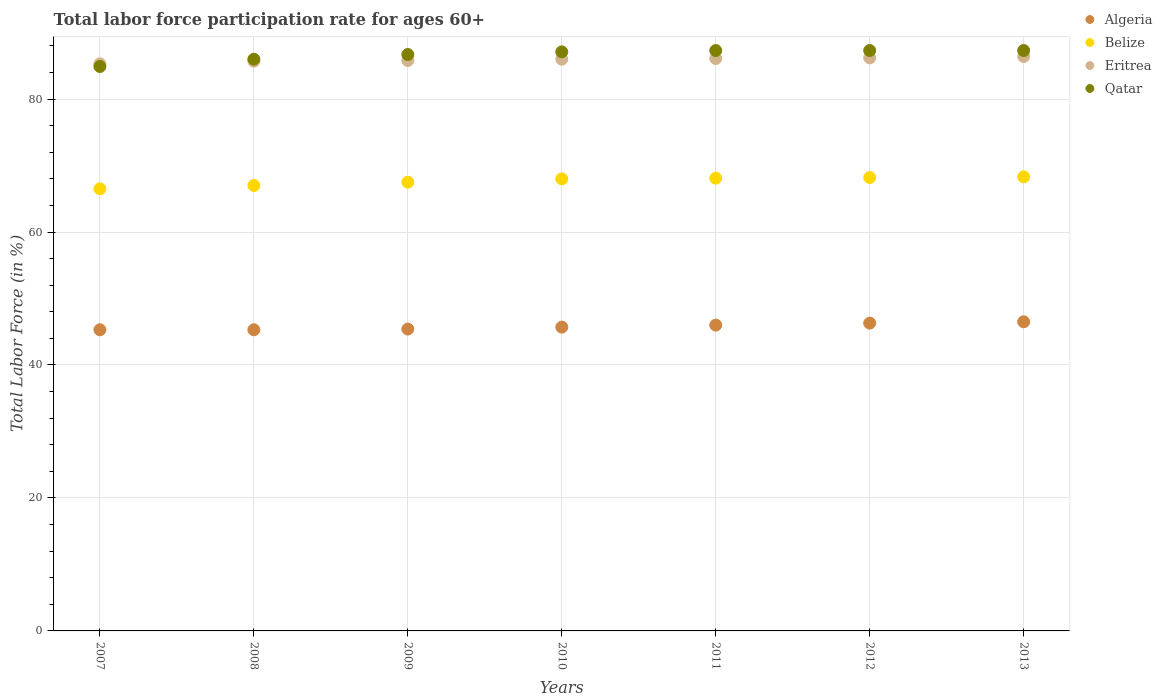How many different coloured dotlines are there?
Your response must be concise. 4. Is the number of dotlines equal to the number of legend labels?
Offer a very short reply. Yes. What is the labor force participation rate in Algeria in 2012?
Ensure brevity in your answer.  46.3. Across all years, what is the maximum labor force participation rate in Algeria?
Your response must be concise. 46.5. Across all years, what is the minimum labor force participation rate in Belize?
Your answer should be very brief. 66.5. What is the total labor force participation rate in Qatar in the graph?
Offer a very short reply. 606.6. What is the difference between the labor force participation rate in Belize in 2011 and that in 2012?
Provide a short and direct response. -0.1. What is the difference between the labor force participation rate in Belize in 2009 and the labor force participation rate in Eritrea in 2010?
Ensure brevity in your answer.  -18.5. What is the average labor force participation rate in Qatar per year?
Offer a very short reply. 86.66. In the year 2013, what is the difference between the labor force participation rate in Qatar and labor force participation rate in Algeria?
Offer a very short reply. 40.8. In how many years, is the labor force participation rate in Algeria greater than 84 %?
Offer a very short reply. 0. What is the ratio of the labor force participation rate in Qatar in 2009 to that in 2013?
Your response must be concise. 0.99. Is the labor force participation rate in Eritrea in 2011 less than that in 2013?
Offer a terse response. Yes. What is the difference between the highest and the second highest labor force participation rate in Qatar?
Provide a succinct answer. 0. What is the difference between the highest and the lowest labor force participation rate in Belize?
Provide a short and direct response. 1.8. Is it the case that in every year, the sum of the labor force participation rate in Belize and labor force participation rate in Qatar  is greater than the sum of labor force participation rate in Algeria and labor force participation rate in Eritrea?
Your answer should be very brief. Yes. Is the labor force participation rate in Eritrea strictly greater than the labor force participation rate in Qatar over the years?
Your response must be concise. No. Is the labor force participation rate in Algeria strictly less than the labor force participation rate in Eritrea over the years?
Your answer should be very brief. Yes. How many dotlines are there?
Offer a terse response. 4. What is the difference between two consecutive major ticks on the Y-axis?
Keep it short and to the point. 20. Does the graph contain any zero values?
Keep it short and to the point. No. Does the graph contain grids?
Your answer should be compact. Yes. What is the title of the graph?
Provide a short and direct response. Total labor force participation rate for ages 60+. What is the Total Labor Force (in %) in Algeria in 2007?
Provide a short and direct response. 45.3. What is the Total Labor Force (in %) in Belize in 2007?
Make the answer very short. 66.5. What is the Total Labor Force (in %) of Eritrea in 2007?
Provide a short and direct response. 85.3. What is the Total Labor Force (in %) of Qatar in 2007?
Make the answer very short. 84.9. What is the Total Labor Force (in %) in Algeria in 2008?
Give a very brief answer. 45.3. What is the Total Labor Force (in %) in Eritrea in 2008?
Ensure brevity in your answer.  85.7. What is the Total Labor Force (in %) of Qatar in 2008?
Provide a succinct answer. 86. What is the Total Labor Force (in %) in Algeria in 2009?
Keep it short and to the point. 45.4. What is the Total Labor Force (in %) of Belize in 2009?
Ensure brevity in your answer.  67.5. What is the Total Labor Force (in %) in Eritrea in 2009?
Your response must be concise. 85.8. What is the Total Labor Force (in %) of Qatar in 2009?
Offer a terse response. 86.7. What is the Total Labor Force (in %) in Algeria in 2010?
Make the answer very short. 45.7. What is the Total Labor Force (in %) in Belize in 2010?
Provide a short and direct response. 68. What is the Total Labor Force (in %) of Eritrea in 2010?
Keep it short and to the point. 86. What is the Total Labor Force (in %) of Qatar in 2010?
Your answer should be very brief. 87.1. What is the Total Labor Force (in %) in Algeria in 2011?
Keep it short and to the point. 46. What is the Total Labor Force (in %) in Belize in 2011?
Your response must be concise. 68.1. What is the Total Labor Force (in %) in Eritrea in 2011?
Make the answer very short. 86.1. What is the Total Labor Force (in %) in Qatar in 2011?
Give a very brief answer. 87.3. What is the Total Labor Force (in %) in Algeria in 2012?
Make the answer very short. 46.3. What is the Total Labor Force (in %) of Belize in 2012?
Keep it short and to the point. 68.2. What is the Total Labor Force (in %) in Eritrea in 2012?
Your response must be concise. 86.2. What is the Total Labor Force (in %) in Qatar in 2012?
Ensure brevity in your answer.  87.3. What is the Total Labor Force (in %) in Algeria in 2013?
Your answer should be very brief. 46.5. What is the Total Labor Force (in %) in Belize in 2013?
Your answer should be compact. 68.3. What is the Total Labor Force (in %) in Eritrea in 2013?
Your answer should be compact. 86.4. What is the Total Labor Force (in %) of Qatar in 2013?
Offer a terse response. 87.3. Across all years, what is the maximum Total Labor Force (in %) in Algeria?
Provide a succinct answer. 46.5. Across all years, what is the maximum Total Labor Force (in %) of Belize?
Your answer should be compact. 68.3. Across all years, what is the maximum Total Labor Force (in %) of Eritrea?
Provide a short and direct response. 86.4. Across all years, what is the maximum Total Labor Force (in %) of Qatar?
Ensure brevity in your answer.  87.3. Across all years, what is the minimum Total Labor Force (in %) of Algeria?
Offer a terse response. 45.3. Across all years, what is the minimum Total Labor Force (in %) of Belize?
Provide a succinct answer. 66.5. Across all years, what is the minimum Total Labor Force (in %) in Eritrea?
Offer a very short reply. 85.3. Across all years, what is the minimum Total Labor Force (in %) of Qatar?
Give a very brief answer. 84.9. What is the total Total Labor Force (in %) in Algeria in the graph?
Offer a terse response. 320.5. What is the total Total Labor Force (in %) of Belize in the graph?
Give a very brief answer. 473.6. What is the total Total Labor Force (in %) in Eritrea in the graph?
Give a very brief answer. 601.5. What is the total Total Labor Force (in %) in Qatar in the graph?
Provide a succinct answer. 606.6. What is the difference between the Total Labor Force (in %) of Algeria in 2007 and that in 2008?
Your response must be concise. 0. What is the difference between the Total Labor Force (in %) in Belize in 2007 and that in 2008?
Ensure brevity in your answer.  -0.5. What is the difference between the Total Labor Force (in %) in Eritrea in 2007 and that in 2008?
Offer a very short reply. -0.4. What is the difference between the Total Labor Force (in %) in Qatar in 2007 and that in 2009?
Your answer should be compact. -1.8. What is the difference between the Total Labor Force (in %) in Algeria in 2007 and that in 2011?
Keep it short and to the point. -0.7. What is the difference between the Total Labor Force (in %) in Belize in 2007 and that in 2011?
Provide a short and direct response. -1.6. What is the difference between the Total Labor Force (in %) of Eritrea in 2007 and that in 2011?
Keep it short and to the point. -0.8. What is the difference between the Total Labor Force (in %) in Qatar in 2007 and that in 2011?
Keep it short and to the point. -2.4. What is the difference between the Total Labor Force (in %) of Eritrea in 2007 and that in 2012?
Keep it short and to the point. -0.9. What is the difference between the Total Labor Force (in %) of Qatar in 2007 and that in 2012?
Offer a very short reply. -2.4. What is the difference between the Total Labor Force (in %) in Algeria in 2007 and that in 2013?
Keep it short and to the point. -1.2. What is the difference between the Total Labor Force (in %) in Belize in 2007 and that in 2013?
Your answer should be very brief. -1.8. What is the difference between the Total Labor Force (in %) in Qatar in 2007 and that in 2013?
Your answer should be very brief. -2.4. What is the difference between the Total Labor Force (in %) in Qatar in 2008 and that in 2009?
Give a very brief answer. -0.7. What is the difference between the Total Labor Force (in %) in Qatar in 2008 and that in 2011?
Make the answer very short. -1.3. What is the difference between the Total Labor Force (in %) in Eritrea in 2008 and that in 2012?
Keep it short and to the point. -0.5. What is the difference between the Total Labor Force (in %) of Eritrea in 2008 and that in 2013?
Offer a terse response. -0.7. What is the difference between the Total Labor Force (in %) in Qatar in 2008 and that in 2013?
Your answer should be compact. -1.3. What is the difference between the Total Labor Force (in %) of Algeria in 2009 and that in 2010?
Provide a short and direct response. -0.3. What is the difference between the Total Labor Force (in %) in Belize in 2009 and that in 2010?
Your response must be concise. -0.5. What is the difference between the Total Labor Force (in %) of Qatar in 2009 and that in 2010?
Provide a succinct answer. -0.4. What is the difference between the Total Labor Force (in %) of Belize in 2009 and that in 2011?
Make the answer very short. -0.6. What is the difference between the Total Labor Force (in %) in Eritrea in 2009 and that in 2011?
Your response must be concise. -0.3. What is the difference between the Total Labor Force (in %) of Qatar in 2009 and that in 2011?
Your answer should be very brief. -0.6. What is the difference between the Total Labor Force (in %) of Belize in 2009 and that in 2012?
Offer a very short reply. -0.7. What is the difference between the Total Labor Force (in %) of Eritrea in 2009 and that in 2012?
Offer a very short reply. -0.4. What is the difference between the Total Labor Force (in %) in Eritrea in 2009 and that in 2013?
Your answer should be very brief. -0.6. What is the difference between the Total Labor Force (in %) of Qatar in 2009 and that in 2013?
Keep it short and to the point. -0.6. What is the difference between the Total Labor Force (in %) in Algeria in 2010 and that in 2011?
Keep it short and to the point. -0.3. What is the difference between the Total Labor Force (in %) in Eritrea in 2010 and that in 2011?
Give a very brief answer. -0.1. What is the difference between the Total Labor Force (in %) of Algeria in 2010 and that in 2012?
Offer a terse response. -0.6. What is the difference between the Total Labor Force (in %) in Eritrea in 2010 and that in 2012?
Give a very brief answer. -0.2. What is the difference between the Total Labor Force (in %) of Algeria in 2010 and that in 2013?
Your response must be concise. -0.8. What is the difference between the Total Labor Force (in %) of Belize in 2010 and that in 2013?
Give a very brief answer. -0.3. What is the difference between the Total Labor Force (in %) of Qatar in 2010 and that in 2013?
Keep it short and to the point. -0.2. What is the difference between the Total Labor Force (in %) in Eritrea in 2011 and that in 2012?
Keep it short and to the point. -0.1. What is the difference between the Total Labor Force (in %) in Belize in 2011 and that in 2013?
Your answer should be compact. -0.2. What is the difference between the Total Labor Force (in %) of Eritrea in 2011 and that in 2013?
Your response must be concise. -0.3. What is the difference between the Total Labor Force (in %) of Qatar in 2011 and that in 2013?
Make the answer very short. 0. What is the difference between the Total Labor Force (in %) in Algeria in 2012 and that in 2013?
Your answer should be very brief. -0.2. What is the difference between the Total Labor Force (in %) in Qatar in 2012 and that in 2013?
Provide a short and direct response. 0. What is the difference between the Total Labor Force (in %) in Algeria in 2007 and the Total Labor Force (in %) in Belize in 2008?
Ensure brevity in your answer.  -21.7. What is the difference between the Total Labor Force (in %) of Algeria in 2007 and the Total Labor Force (in %) of Eritrea in 2008?
Your answer should be very brief. -40.4. What is the difference between the Total Labor Force (in %) in Algeria in 2007 and the Total Labor Force (in %) in Qatar in 2008?
Your response must be concise. -40.7. What is the difference between the Total Labor Force (in %) in Belize in 2007 and the Total Labor Force (in %) in Eritrea in 2008?
Offer a very short reply. -19.2. What is the difference between the Total Labor Force (in %) in Belize in 2007 and the Total Labor Force (in %) in Qatar in 2008?
Make the answer very short. -19.5. What is the difference between the Total Labor Force (in %) in Eritrea in 2007 and the Total Labor Force (in %) in Qatar in 2008?
Offer a terse response. -0.7. What is the difference between the Total Labor Force (in %) of Algeria in 2007 and the Total Labor Force (in %) of Belize in 2009?
Provide a short and direct response. -22.2. What is the difference between the Total Labor Force (in %) in Algeria in 2007 and the Total Labor Force (in %) in Eritrea in 2009?
Provide a succinct answer. -40.5. What is the difference between the Total Labor Force (in %) of Algeria in 2007 and the Total Labor Force (in %) of Qatar in 2009?
Your response must be concise. -41.4. What is the difference between the Total Labor Force (in %) in Belize in 2007 and the Total Labor Force (in %) in Eritrea in 2009?
Make the answer very short. -19.3. What is the difference between the Total Labor Force (in %) in Belize in 2007 and the Total Labor Force (in %) in Qatar in 2009?
Make the answer very short. -20.2. What is the difference between the Total Labor Force (in %) of Eritrea in 2007 and the Total Labor Force (in %) of Qatar in 2009?
Offer a very short reply. -1.4. What is the difference between the Total Labor Force (in %) in Algeria in 2007 and the Total Labor Force (in %) in Belize in 2010?
Your response must be concise. -22.7. What is the difference between the Total Labor Force (in %) in Algeria in 2007 and the Total Labor Force (in %) in Eritrea in 2010?
Provide a short and direct response. -40.7. What is the difference between the Total Labor Force (in %) in Algeria in 2007 and the Total Labor Force (in %) in Qatar in 2010?
Make the answer very short. -41.8. What is the difference between the Total Labor Force (in %) of Belize in 2007 and the Total Labor Force (in %) of Eritrea in 2010?
Your response must be concise. -19.5. What is the difference between the Total Labor Force (in %) of Belize in 2007 and the Total Labor Force (in %) of Qatar in 2010?
Keep it short and to the point. -20.6. What is the difference between the Total Labor Force (in %) in Algeria in 2007 and the Total Labor Force (in %) in Belize in 2011?
Your answer should be very brief. -22.8. What is the difference between the Total Labor Force (in %) of Algeria in 2007 and the Total Labor Force (in %) of Eritrea in 2011?
Provide a short and direct response. -40.8. What is the difference between the Total Labor Force (in %) in Algeria in 2007 and the Total Labor Force (in %) in Qatar in 2011?
Your response must be concise. -42. What is the difference between the Total Labor Force (in %) in Belize in 2007 and the Total Labor Force (in %) in Eritrea in 2011?
Provide a short and direct response. -19.6. What is the difference between the Total Labor Force (in %) in Belize in 2007 and the Total Labor Force (in %) in Qatar in 2011?
Your response must be concise. -20.8. What is the difference between the Total Labor Force (in %) in Algeria in 2007 and the Total Labor Force (in %) in Belize in 2012?
Make the answer very short. -22.9. What is the difference between the Total Labor Force (in %) of Algeria in 2007 and the Total Labor Force (in %) of Eritrea in 2012?
Keep it short and to the point. -40.9. What is the difference between the Total Labor Force (in %) of Algeria in 2007 and the Total Labor Force (in %) of Qatar in 2012?
Provide a short and direct response. -42. What is the difference between the Total Labor Force (in %) of Belize in 2007 and the Total Labor Force (in %) of Eritrea in 2012?
Offer a terse response. -19.7. What is the difference between the Total Labor Force (in %) of Belize in 2007 and the Total Labor Force (in %) of Qatar in 2012?
Offer a very short reply. -20.8. What is the difference between the Total Labor Force (in %) of Eritrea in 2007 and the Total Labor Force (in %) of Qatar in 2012?
Offer a terse response. -2. What is the difference between the Total Labor Force (in %) in Algeria in 2007 and the Total Labor Force (in %) in Belize in 2013?
Your response must be concise. -23. What is the difference between the Total Labor Force (in %) of Algeria in 2007 and the Total Labor Force (in %) of Eritrea in 2013?
Make the answer very short. -41.1. What is the difference between the Total Labor Force (in %) of Algeria in 2007 and the Total Labor Force (in %) of Qatar in 2013?
Offer a very short reply. -42. What is the difference between the Total Labor Force (in %) of Belize in 2007 and the Total Labor Force (in %) of Eritrea in 2013?
Offer a terse response. -19.9. What is the difference between the Total Labor Force (in %) of Belize in 2007 and the Total Labor Force (in %) of Qatar in 2013?
Give a very brief answer. -20.8. What is the difference between the Total Labor Force (in %) in Algeria in 2008 and the Total Labor Force (in %) in Belize in 2009?
Your response must be concise. -22.2. What is the difference between the Total Labor Force (in %) of Algeria in 2008 and the Total Labor Force (in %) of Eritrea in 2009?
Keep it short and to the point. -40.5. What is the difference between the Total Labor Force (in %) in Algeria in 2008 and the Total Labor Force (in %) in Qatar in 2009?
Your response must be concise. -41.4. What is the difference between the Total Labor Force (in %) of Belize in 2008 and the Total Labor Force (in %) of Eritrea in 2009?
Your answer should be very brief. -18.8. What is the difference between the Total Labor Force (in %) in Belize in 2008 and the Total Labor Force (in %) in Qatar in 2009?
Offer a terse response. -19.7. What is the difference between the Total Labor Force (in %) in Eritrea in 2008 and the Total Labor Force (in %) in Qatar in 2009?
Your response must be concise. -1. What is the difference between the Total Labor Force (in %) in Algeria in 2008 and the Total Labor Force (in %) in Belize in 2010?
Your answer should be compact. -22.7. What is the difference between the Total Labor Force (in %) in Algeria in 2008 and the Total Labor Force (in %) in Eritrea in 2010?
Keep it short and to the point. -40.7. What is the difference between the Total Labor Force (in %) of Algeria in 2008 and the Total Labor Force (in %) of Qatar in 2010?
Your response must be concise. -41.8. What is the difference between the Total Labor Force (in %) in Belize in 2008 and the Total Labor Force (in %) in Qatar in 2010?
Keep it short and to the point. -20.1. What is the difference between the Total Labor Force (in %) in Algeria in 2008 and the Total Labor Force (in %) in Belize in 2011?
Offer a very short reply. -22.8. What is the difference between the Total Labor Force (in %) of Algeria in 2008 and the Total Labor Force (in %) of Eritrea in 2011?
Give a very brief answer. -40.8. What is the difference between the Total Labor Force (in %) of Algeria in 2008 and the Total Labor Force (in %) of Qatar in 2011?
Your answer should be compact. -42. What is the difference between the Total Labor Force (in %) in Belize in 2008 and the Total Labor Force (in %) in Eritrea in 2011?
Provide a succinct answer. -19.1. What is the difference between the Total Labor Force (in %) of Belize in 2008 and the Total Labor Force (in %) of Qatar in 2011?
Keep it short and to the point. -20.3. What is the difference between the Total Labor Force (in %) of Algeria in 2008 and the Total Labor Force (in %) of Belize in 2012?
Offer a terse response. -22.9. What is the difference between the Total Labor Force (in %) of Algeria in 2008 and the Total Labor Force (in %) of Eritrea in 2012?
Your answer should be very brief. -40.9. What is the difference between the Total Labor Force (in %) in Algeria in 2008 and the Total Labor Force (in %) in Qatar in 2012?
Give a very brief answer. -42. What is the difference between the Total Labor Force (in %) of Belize in 2008 and the Total Labor Force (in %) of Eritrea in 2012?
Your answer should be compact. -19.2. What is the difference between the Total Labor Force (in %) in Belize in 2008 and the Total Labor Force (in %) in Qatar in 2012?
Your answer should be very brief. -20.3. What is the difference between the Total Labor Force (in %) of Algeria in 2008 and the Total Labor Force (in %) of Belize in 2013?
Ensure brevity in your answer.  -23. What is the difference between the Total Labor Force (in %) in Algeria in 2008 and the Total Labor Force (in %) in Eritrea in 2013?
Provide a succinct answer. -41.1. What is the difference between the Total Labor Force (in %) of Algeria in 2008 and the Total Labor Force (in %) of Qatar in 2013?
Provide a short and direct response. -42. What is the difference between the Total Labor Force (in %) in Belize in 2008 and the Total Labor Force (in %) in Eritrea in 2013?
Your answer should be compact. -19.4. What is the difference between the Total Labor Force (in %) in Belize in 2008 and the Total Labor Force (in %) in Qatar in 2013?
Ensure brevity in your answer.  -20.3. What is the difference between the Total Labor Force (in %) of Algeria in 2009 and the Total Labor Force (in %) of Belize in 2010?
Your response must be concise. -22.6. What is the difference between the Total Labor Force (in %) in Algeria in 2009 and the Total Labor Force (in %) in Eritrea in 2010?
Your answer should be compact. -40.6. What is the difference between the Total Labor Force (in %) of Algeria in 2009 and the Total Labor Force (in %) of Qatar in 2010?
Offer a terse response. -41.7. What is the difference between the Total Labor Force (in %) of Belize in 2009 and the Total Labor Force (in %) of Eritrea in 2010?
Make the answer very short. -18.5. What is the difference between the Total Labor Force (in %) in Belize in 2009 and the Total Labor Force (in %) in Qatar in 2010?
Your answer should be compact. -19.6. What is the difference between the Total Labor Force (in %) of Eritrea in 2009 and the Total Labor Force (in %) of Qatar in 2010?
Offer a terse response. -1.3. What is the difference between the Total Labor Force (in %) of Algeria in 2009 and the Total Labor Force (in %) of Belize in 2011?
Offer a very short reply. -22.7. What is the difference between the Total Labor Force (in %) in Algeria in 2009 and the Total Labor Force (in %) in Eritrea in 2011?
Your answer should be compact. -40.7. What is the difference between the Total Labor Force (in %) in Algeria in 2009 and the Total Labor Force (in %) in Qatar in 2011?
Give a very brief answer. -41.9. What is the difference between the Total Labor Force (in %) of Belize in 2009 and the Total Labor Force (in %) of Eritrea in 2011?
Your response must be concise. -18.6. What is the difference between the Total Labor Force (in %) in Belize in 2009 and the Total Labor Force (in %) in Qatar in 2011?
Offer a very short reply. -19.8. What is the difference between the Total Labor Force (in %) of Algeria in 2009 and the Total Labor Force (in %) of Belize in 2012?
Offer a terse response. -22.8. What is the difference between the Total Labor Force (in %) in Algeria in 2009 and the Total Labor Force (in %) in Eritrea in 2012?
Your answer should be very brief. -40.8. What is the difference between the Total Labor Force (in %) of Algeria in 2009 and the Total Labor Force (in %) of Qatar in 2012?
Provide a succinct answer. -41.9. What is the difference between the Total Labor Force (in %) of Belize in 2009 and the Total Labor Force (in %) of Eritrea in 2012?
Your answer should be compact. -18.7. What is the difference between the Total Labor Force (in %) of Belize in 2009 and the Total Labor Force (in %) of Qatar in 2012?
Provide a short and direct response. -19.8. What is the difference between the Total Labor Force (in %) of Eritrea in 2009 and the Total Labor Force (in %) of Qatar in 2012?
Your answer should be compact. -1.5. What is the difference between the Total Labor Force (in %) of Algeria in 2009 and the Total Labor Force (in %) of Belize in 2013?
Provide a succinct answer. -22.9. What is the difference between the Total Labor Force (in %) in Algeria in 2009 and the Total Labor Force (in %) in Eritrea in 2013?
Make the answer very short. -41. What is the difference between the Total Labor Force (in %) of Algeria in 2009 and the Total Labor Force (in %) of Qatar in 2013?
Keep it short and to the point. -41.9. What is the difference between the Total Labor Force (in %) of Belize in 2009 and the Total Labor Force (in %) of Eritrea in 2013?
Ensure brevity in your answer.  -18.9. What is the difference between the Total Labor Force (in %) of Belize in 2009 and the Total Labor Force (in %) of Qatar in 2013?
Your response must be concise. -19.8. What is the difference between the Total Labor Force (in %) of Algeria in 2010 and the Total Labor Force (in %) of Belize in 2011?
Ensure brevity in your answer.  -22.4. What is the difference between the Total Labor Force (in %) in Algeria in 2010 and the Total Labor Force (in %) in Eritrea in 2011?
Your response must be concise. -40.4. What is the difference between the Total Labor Force (in %) in Algeria in 2010 and the Total Labor Force (in %) in Qatar in 2011?
Give a very brief answer. -41.6. What is the difference between the Total Labor Force (in %) of Belize in 2010 and the Total Labor Force (in %) of Eritrea in 2011?
Give a very brief answer. -18.1. What is the difference between the Total Labor Force (in %) of Belize in 2010 and the Total Labor Force (in %) of Qatar in 2011?
Your answer should be very brief. -19.3. What is the difference between the Total Labor Force (in %) in Algeria in 2010 and the Total Labor Force (in %) in Belize in 2012?
Provide a short and direct response. -22.5. What is the difference between the Total Labor Force (in %) of Algeria in 2010 and the Total Labor Force (in %) of Eritrea in 2012?
Offer a terse response. -40.5. What is the difference between the Total Labor Force (in %) of Algeria in 2010 and the Total Labor Force (in %) of Qatar in 2012?
Offer a very short reply. -41.6. What is the difference between the Total Labor Force (in %) in Belize in 2010 and the Total Labor Force (in %) in Eritrea in 2012?
Offer a very short reply. -18.2. What is the difference between the Total Labor Force (in %) of Belize in 2010 and the Total Labor Force (in %) of Qatar in 2012?
Offer a terse response. -19.3. What is the difference between the Total Labor Force (in %) of Eritrea in 2010 and the Total Labor Force (in %) of Qatar in 2012?
Provide a succinct answer. -1.3. What is the difference between the Total Labor Force (in %) of Algeria in 2010 and the Total Labor Force (in %) of Belize in 2013?
Provide a short and direct response. -22.6. What is the difference between the Total Labor Force (in %) in Algeria in 2010 and the Total Labor Force (in %) in Eritrea in 2013?
Provide a short and direct response. -40.7. What is the difference between the Total Labor Force (in %) in Algeria in 2010 and the Total Labor Force (in %) in Qatar in 2013?
Ensure brevity in your answer.  -41.6. What is the difference between the Total Labor Force (in %) in Belize in 2010 and the Total Labor Force (in %) in Eritrea in 2013?
Offer a terse response. -18.4. What is the difference between the Total Labor Force (in %) in Belize in 2010 and the Total Labor Force (in %) in Qatar in 2013?
Offer a very short reply. -19.3. What is the difference between the Total Labor Force (in %) of Eritrea in 2010 and the Total Labor Force (in %) of Qatar in 2013?
Your answer should be compact. -1.3. What is the difference between the Total Labor Force (in %) of Algeria in 2011 and the Total Labor Force (in %) of Belize in 2012?
Ensure brevity in your answer.  -22.2. What is the difference between the Total Labor Force (in %) in Algeria in 2011 and the Total Labor Force (in %) in Eritrea in 2012?
Provide a succinct answer. -40.2. What is the difference between the Total Labor Force (in %) in Algeria in 2011 and the Total Labor Force (in %) in Qatar in 2012?
Keep it short and to the point. -41.3. What is the difference between the Total Labor Force (in %) of Belize in 2011 and the Total Labor Force (in %) of Eritrea in 2012?
Ensure brevity in your answer.  -18.1. What is the difference between the Total Labor Force (in %) in Belize in 2011 and the Total Labor Force (in %) in Qatar in 2012?
Keep it short and to the point. -19.2. What is the difference between the Total Labor Force (in %) in Algeria in 2011 and the Total Labor Force (in %) in Belize in 2013?
Offer a terse response. -22.3. What is the difference between the Total Labor Force (in %) in Algeria in 2011 and the Total Labor Force (in %) in Eritrea in 2013?
Offer a terse response. -40.4. What is the difference between the Total Labor Force (in %) in Algeria in 2011 and the Total Labor Force (in %) in Qatar in 2013?
Offer a terse response. -41.3. What is the difference between the Total Labor Force (in %) in Belize in 2011 and the Total Labor Force (in %) in Eritrea in 2013?
Give a very brief answer. -18.3. What is the difference between the Total Labor Force (in %) of Belize in 2011 and the Total Labor Force (in %) of Qatar in 2013?
Offer a terse response. -19.2. What is the difference between the Total Labor Force (in %) in Eritrea in 2011 and the Total Labor Force (in %) in Qatar in 2013?
Make the answer very short. -1.2. What is the difference between the Total Labor Force (in %) of Algeria in 2012 and the Total Labor Force (in %) of Belize in 2013?
Provide a short and direct response. -22. What is the difference between the Total Labor Force (in %) of Algeria in 2012 and the Total Labor Force (in %) of Eritrea in 2013?
Offer a very short reply. -40.1. What is the difference between the Total Labor Force (in %) of Algeria in 2012 and the Total Labor Force (in %) of Qatar in 2013?
Keep it short and to the point. -41. What is the difference between the Total Labor Force (in %) in Belize in 2012 and the Total Labor Force (in %) in Eritrea in 2013?
Make the answer very short. -18.2. What is the difference between the Total Labor Force (in %) in Belize in 2012 and the Total Labor Force (in %) in Qatar in 2013?
Provide a short and direct response. -19.1. What is the average Total Labor Force (in %) of Algeria per year?
Your answer should be very brief. 45.79. What is the average Total Labor Force (in %) in Belize per year?
Make the answer very short. 67.66. What is the average Total Labor Force (in %) of Eritrea per year?
Ensure brevity in your answer.  85.93. What is the average Total Labor Force (in %) of Qatar per year?
Keep it short and to the point. 86.66. In the year 2007, what is the difference between the Total Labor Force (in %) of Algeria and Total Labor Force (in %) of Belize?
Offer a terse response. -21.2. In the year 2007, what is the difference between the Total Labor Force (in %) in Algeria and Total Labor Force (in %) in Eritrea?
Give a very brief answer. -40. In the year 2007, what is the difference between the Total Labor Force (in %) of Algeria and Total Labor Force (in %) of Qatar?
Offer a very short reply. -39.6. In the year 2007, what is the difference between the Total Labor Force (in %) of Belize and Total Labor Force (in %) of Eritrea?
Keep it short and to the point. -18.8. In the year 2007, what is the difference between the Total Labor Force (in %) in Belize and Total Labor Force (in %) in Qatar?
Provide a short and direct response. -18.4. In the year 2007, what is the difference between the Total Labor Force (in %) of Eritrea and Total Labor Force (in %) of Qatar?
Give a very brief answer. 0.4. In the year 2008, what is the difference between the Total Labor Force (in %) in Algeria and Total Labor Force (in %) in Belize?
Give a very brief answer. -21.7. In the year 2008, what is the difference between the Total Labor Force (in %) in Algeria and Total Labor Force (in %) in Eritrea?
Offer a terse response. -40.4. In the year 2008, what is the difference between the Total Labor Force (in %) in Algeria and Total Labor Force (in %) in Qatar?
Keep it short and to the point. -40.7. In the year 2008, what is the difference between the Total Labor Force (in %) of Belize and Total Labor Force (in %) of Eritrea?
Your answer should be compact. -18.7. In the year 2008, what is the difference between the Total Labor Force (in %) of Belize and Total Labor Force (in %) of Qatar?
Offer a very short reply. -19. In the year 2009, what is the difference between the Total Labor Force (in %) in Algeria and Total Labor Force (in %) in Belize?
Keep it short and to the point. -22.1. In the year 2009, what is the difference between the Total Labor Force (in %) in Algeria and Total Labor Force (in %) in Eritrea?
Ensure brevity in your answer.  -40.4. In the year 2009, what is the difference between the Total Labor Force (in %) of Algeria and Total Labor Force (in %) of Qatar?
Your answer should be very brief. -41.3. In the year 2009, what is the difference between the Total Labor Force (in %) in Belize and Total Labor Force (in %) in Eritrea?
Make the answer very short. -18.3. In the year 2009, what is the difference between the Total Labor Force (in %) in Belize and Total Labor Force (in %) in Qatar?
Offer a very short reply. -19.2. In the year 2010, what is the difference between the Total Labor Force (in %) of Algeria and Total Labor Force (in %) of Belize?
Offer a very short reply. -22.3. In the year 2010, what is the difference between the Total Labor Force (in %) in Algeria and Total Labor Force (in %) in Eritrea?
Give a very brief answer. -40.3. In the year 2010, what is the difference between the Total Labor Force (in %) of Algeria and Total Labor Force (in %) of Qatar?
Make the answer very short. -41.4. In the year 2010, what is the difference between the Total Labor Force (in %) of Belize and Total Labor Force (in %) of Qatar?
Provide a succinct answer. -19.1. In the year 2011, what is the difference between the Total Labor Force (in %) in Algeria and Total Labor Force (in %) in Belize?
Your response must be concise. -22.1. In the year 2011, what is the difference between the Total Labor Force (in %) in Algeria and Total Labor Force (in %) in Eritrea?
Offer a very short reply. -40.1. In the year 2011, what is the difference between the Total Labor Force (in %) of Algeria and Total Labor Force (in %) of Qatar?
Provide a succinct answer. -41.3. In the year 2011, what is the difference between the Total Labor Force (in %) of Belize and Total Labor Force (in %) of Eritrea?
Offer a terse response. -18. In the year 2011, what is the difference between the Total Labor Force (in %) in Belize and Total Labor Force (in %) in Qatar?
Your answer should be very brief. -19.2. In the year 2011, what is the difference between the Total Labor Force (in %) in Eritrea and Total Labor Force (in %) in Qatar?
Provide a short and direct response. -1.2. In the year 2012, what is the difference between the Total Labor Force (in %) in Algeria and Total Labor Force (in %) in Belize?
Offer a very short reply. -21.9. In the year 2012, what is the difference between the Total Labor Force (in %) of Algeria and Total Labor Force (in %) of Eritrea?
Offer a very short reply. -39.9. In the year 2012, what is the difference between the Total Labor Force (in %) of Algeria and Total Labor Force (in %) of Qatar?
Provide a short and direct response. -41. In the year 2012, what is the difference between the Total Labor Force (in %) in Belize and Total Labor Force (in %) in Qatar?
Your answer should be very brief. -19.1. In the year 2013, what is the difference between the Total Labor Force (in %) of Algeria and Total Labor Force (in %) of Belize?
Give a very brief answer. -21.8. In the year 2013, what is the difference between the Total Labor Force (in %) of Algeria and Total Labor Force (in %) of Eritrea?
Give a very brief answer. -39.9. In the year 2013, what is the difference between the Total Labor Force (in %) of Algeria and Total Labor Force (in %) of Qatar?
Provide a succinct answer. -40.8. In the year 2013, what is the difference between the Total Labor Force (in %) in Belize and Total Labor Force (in %) in Eritrea?
Give a very brief answer. -18.1. In the year 2013, what is the difference between the Total Labor Force (in %) of Eritrea and Total Labor Force (in %) of Qatar?
Offer a very short reply. -0.9. What is the ratio of the Total Labor Force (in %) of Belize in 2007 to that in 2008?
Offer a terse response. 0.99. What is the ratio of the Total Labor Force (in %) in Qatar in 2007 to that in 2008?
Give a very brief answer. 0.99. What is the ratio of the Total Labor Force (in %) in Algeria in 2007 to that in 2009?
Make the answer very short. 1. What is the ratio of the Total Labor Force (in %) in Belize in 2007 to that in 2009?
Make the answer very short. 0.99. What is the ratio of the Total Labor Force (in %) of Qatar in 2007 to that in 2009?
Offer a very short reply. 0.98. What is the ratio of the Total Labor Force (in %) in Belize in 2007 to that in 2010?
Keep it short and to the point. 0.98. What is the ratio of the Total Labor Force (in %) in Eritrea in 2007 to that in 2010?
Ensure brevity in your answer.  0.99. What is the ratio of the Total Labor Force (in %) in Qatar in 2007 to that in 2010?
Ensure brevity in your answer.  0.97. What is the ratio of the Total Labor Force (in %) of Belize in 2007 to that in 2011?
Your response must be concise. 0.98. What is the ratio of the Total Labor Force (in %) in Qatar in 2007 to that in 2011?
Your answer should be compact. 0.97. What is the ratio of the Total Labor Force (in %) of Algeria in 2007 to that in 2012?
Provide a short and direct response. 0.98. What is the ratio of the Total Labor Force (in %) of Belize in 2007 to that in 2012?
Ensure brevity in your answer.  0.98. What is the ratio of the Total Labor Force (in %) in Qatar in 2007 to that in 2012?
Offer a terse response. 0.97. What is the ratio of the Total Labor Force (in %) of Algeria in 2007 to that in 2013?
Make the answer very short. 0.97. What is the ratio of the Total Labor Force (in %) of Belize in 2007 to that in 2013?
Offer a very short reply. 0.97. What is the ratio of the Total Labor Force (in %) of Eritrea in 2007 to that in 2013?
Make the answer very short. 0.99. What is the ratio of the Total Labor Force (in %) of Qatar in 2007 to that in 2013?
Your response must be concise. 0.97. What is the ratio of the Total Labor Force (in %) of Algeria in 2008 to that in 2009?
Provide a short and direct response. 1. What is the ratio of the Total Labor Force (in %) of Belize in 2008 to that in 2009?
Your answer should be compact. 0.99. What is the ratio of the Total Labor Force (in %) in Belize in 2008 to that in 2010?
Your answer should be very brief. 0.99. What is the ratio of the Total Labor Force (in %) of Qatar in 2008 to that in 2010?
Make the answer very short. 0.99. What is the ratio of the Total Labor Force (in %) in Belize in 2008 to that in 2011?
Your response must be concise. 0.98. What is the ratio of the Total Labor Force (in %) in Qatar in 2008 to that in 2011?
Your answer should be compact. 0.99. What is the ratio of the Total Labor Force (in %) in Algeria in 2008 to that in 2012?
Provide a succinct answer. 0.98. What is the ratio of the Total Labor Force (in %) in Belize in 2008 to that in 2012?
Ensure brevity in your answer.  0.98. What is the ratio of the Total Labor Force (in %) of Qatar in 2008 to that in 2012?
Offer a very short reply. 0.99. What is the ratio of the Total Labor Force (in %) in Algeria in 2008 to that in 2013?
Give a very brief answer. 0.97. What is the ratio of the Total Labor Force (in %) of Eritrea in 2008 to that in 2013?
Make the answer very short. 0.99. What is the ratio of the Total Labor Force (in %) of Qatar in 2008 to that in 2013?
Keep it short and to the point. 0.99. What is the ratio of the Total Labor Force (in %) of Belize in 2009 to that in 2010?
Make the answer very short. 0.99. What is the ratio of the Total Labor Force (in %) in Qatar in 2009 to that in 2010?
Give a very brief answer. 1. What is the ratio of the Total Labor Force (in %) of Algeria in 2009 to that in 2011?
Make the answer very short. 0.99. What is the ratio of the Total Labor Force (in %) in Algeria in 2009 to that in 2012?
Give a very brief answer. 0.98. What is the ratio of the Total Labor Force (in %) in Eritrea in 2009 to that in 2012?
Provide a short and direct response. 1. What is the ratio of the Total Labor Force (in %) in Qatar in 2009 to that in 2012?
Your response must be concise. 0.99. What is the ratio of the Total Labor Force (in %) of Algeria in 2009 to that in 2013?
Give a very brief answer. 0.98. What is the ratio of the Total Labor Force (in %) of Belize in 2009 to that in 2013?
Provide a succinct answer. 0.99. What is the ratio of the Total Labor Force (in %) of Eritrea in 2009 to that in 2013?
Your response must be concise. 0.99. What is the ratio of the Total Labor Force (in %) of Algeria in 2010 to that in 2011?
Offer a very short reply. 0.99. What is the ratio of the Total Labor Force (in %) of Algeria in 2010 to that in 2012?
Offer a terse response. 0.99. What is the ratio of the Total Labor Force (in %) of Algeria in 2010 to that in 2013?
Your answer should be very brief. 0.98. What is the ratio of the Total Labor Force (in %) in Belize in 2010 to that in 2013?
Your answer should be very brief. 1. What is the ratio of the Total Labor Force (in %) of Eritrea in 2010 to that in 2013?
Keep it short and to the point. 1. What is the ratio of the Total Labor Force (in %) of Algeria in 2011 to that in 2012?
Provide a short and direct response. 0.99. What is the ratio of the Total Labor Force (in %) of Belize in 2011 to that in 2012?
Make the answer very short. 1. What is the ratio of the Total Labor Force (in %) in Eritrea in 2011 to that in 2012?
Your answer should be very brief. 1. What is the ratio of the Total Labor Force (in %) of Algeria in 2011 to that in 2013?
Your answer should be compact. 0.99. What is the ratio of the Total Labor Force (in %) of Belize in 2012 to that in 2013?
Offer a terse response. 1. What is the difference between the highest and the lowest Total Labor Force (in %) of Belize?
Provide a succinct answer. 1.8. What is the difference between the highest and the lowest Total Labor Force (in %) of Qatar?
Your answer should be very brief. 2.4. 